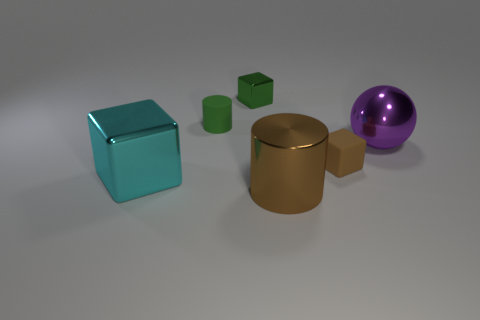Subtract all large blocks. How many blocks are left? 2 Subtract 1 spheres. How many spheres are left? 0 Add 2 tiny cylinders. How many objects exist? 8 Subtract all brown cylinders. How many cylinders are left? 1 Subtract all cylinders. How many objects are left? 4 Subtract all brown cylinders. How many brown cubes are left? 1 Add 1 brown metal cylinders. How many brown metal cylinders are left? 2 Add 6 cyan blocks. How many cyan blocks exist? 7 Subtract 0 yellow cubes. How many objects are left? 6 Subtract all blue blocks. Subtract all blue cylinders. How many blocks are left? 3 